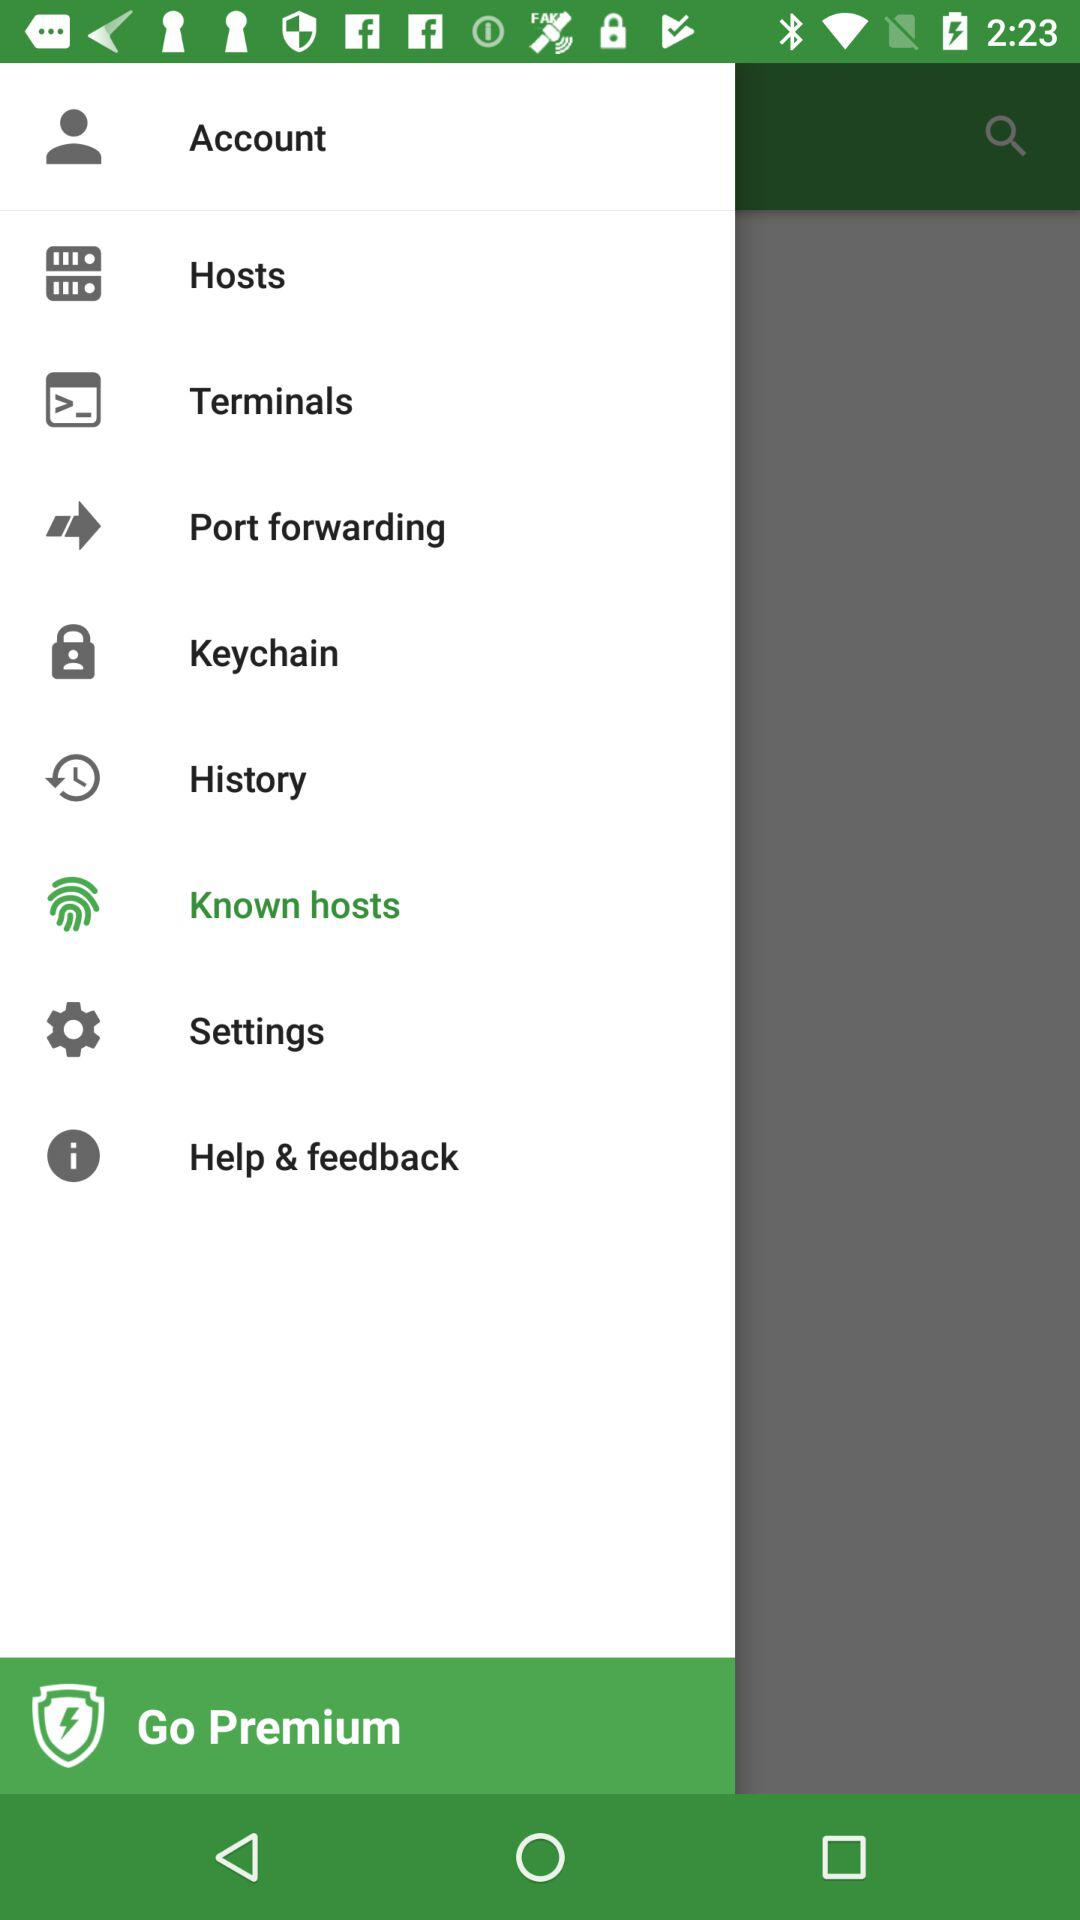Which terminals are provided?
When the provided information is insufficient, respond with <no answer>. <no answer> 